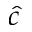<formula> <loc_0><loc_0><loc_500><loc_500>\hat { c }</formula> 